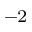<formula> <loc_0><loc_0><loc_500><loc_500>^ { - 2 }</formula> 